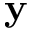<formula> <loc_0><loc_0><loc_500><loc_500>y</formula> 